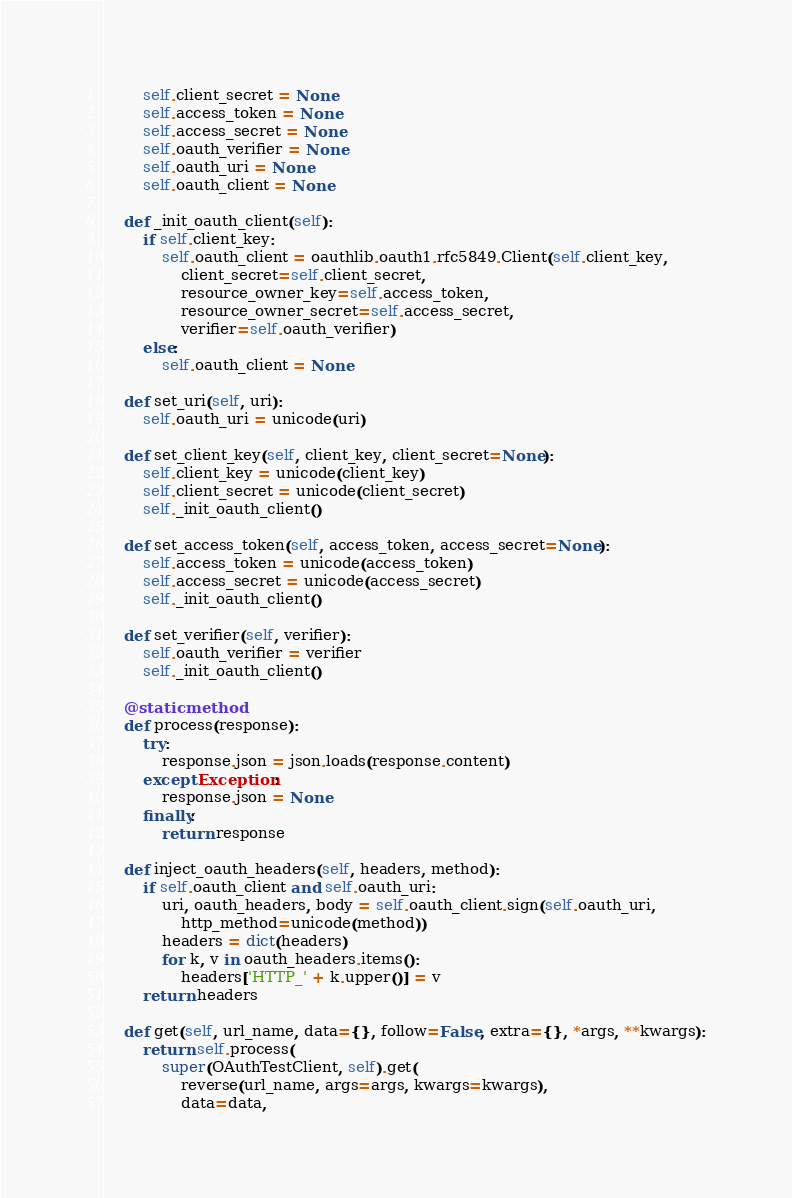<code> <loc_0><loc_0><loc_500><loc_500><_Python_>        self.client_secret = None
        self.access_token = None
        self.access_secret = None
        self.oauth_verifier = None
        self.oauth_uri = None
        self.oauth_client = None

    def _init_oauth_client(self):
        if self.client_key:
            self.oauth_client = oauthlib.oauth1.rfc5849.Client(self.client_key,
                client_secret=self.client_secret,
                resource_owner_key=self.access_token,
                resource_owner_secret=self.access_secret,
                verifier=self.oauth_verifier)
        else:
            self.oauth_client = None

    def set_uri(self, uri):
        self.oauth_uri = unicode(uri)

    def set_client_key(self, client_key, client_secret=None):
        self.client_key = unicode(client_key)
        self.client_secret = unicode(client_secret)
        self._init_oauth_client()

    def set_access_token(self, access_token, access_secret=None):
        self.access_token = unicode(access_token)
        self.access_secret = unicode(access_secret)
        self._init_oauth_client()

    def set_verifier(self, verifier):
        self.oauth_verifier = verifier
        self._init_oauth_client()

    @staticmethod
    def process(response):
        try:
            response.json = json.loads(response.content)
        except Exception:
            response.json = None
        finally:
            return response

    def inject_oauth_headers(self, headers, method):
        if self.oauth_client and self.oauth_uri:
            uri, oauth_headers, body = self.oauth_client.sign(self.oauth_uri,
                http_method=unicode(method))
            headers = dict(headers)
            for k, v in oauth_headers.items():
                headers['HTTP_' + k.upper()] = v
        return headers

    def get(self, url_name, data={}, follow=False, extra={}, *args, **kwargs):
        return self.process(
            super(OAuthTestClient, self).get(
                reverse(url_name, args=args, kwargs=kwargs),
                data=data,</code> 